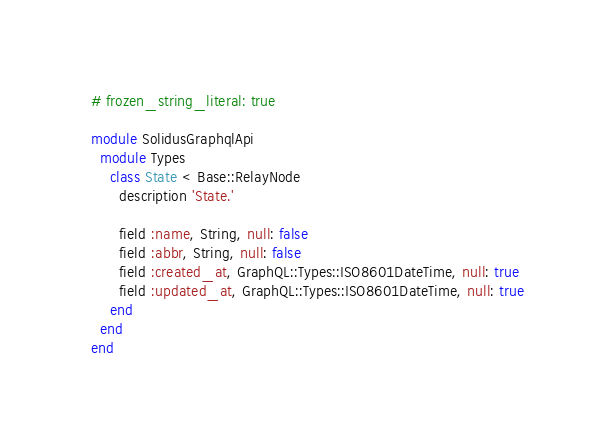<code> <loc_0><loc_0><loc_500><loc_500><_Ruby_># frozen_string_literal: true

module SolidusGraphqlApi
  module Types
    class State < Base::RelayNode
      description 'State.'

      field :name, String, null: false
      field :abbr, String, null: false
      field :created_at, GraphQL::Types::ISO8601DateTime, null: true
      field :updated_at, GraphQL::Types::ISO8601DateTime, null: true
    end
  end
end
</code> 